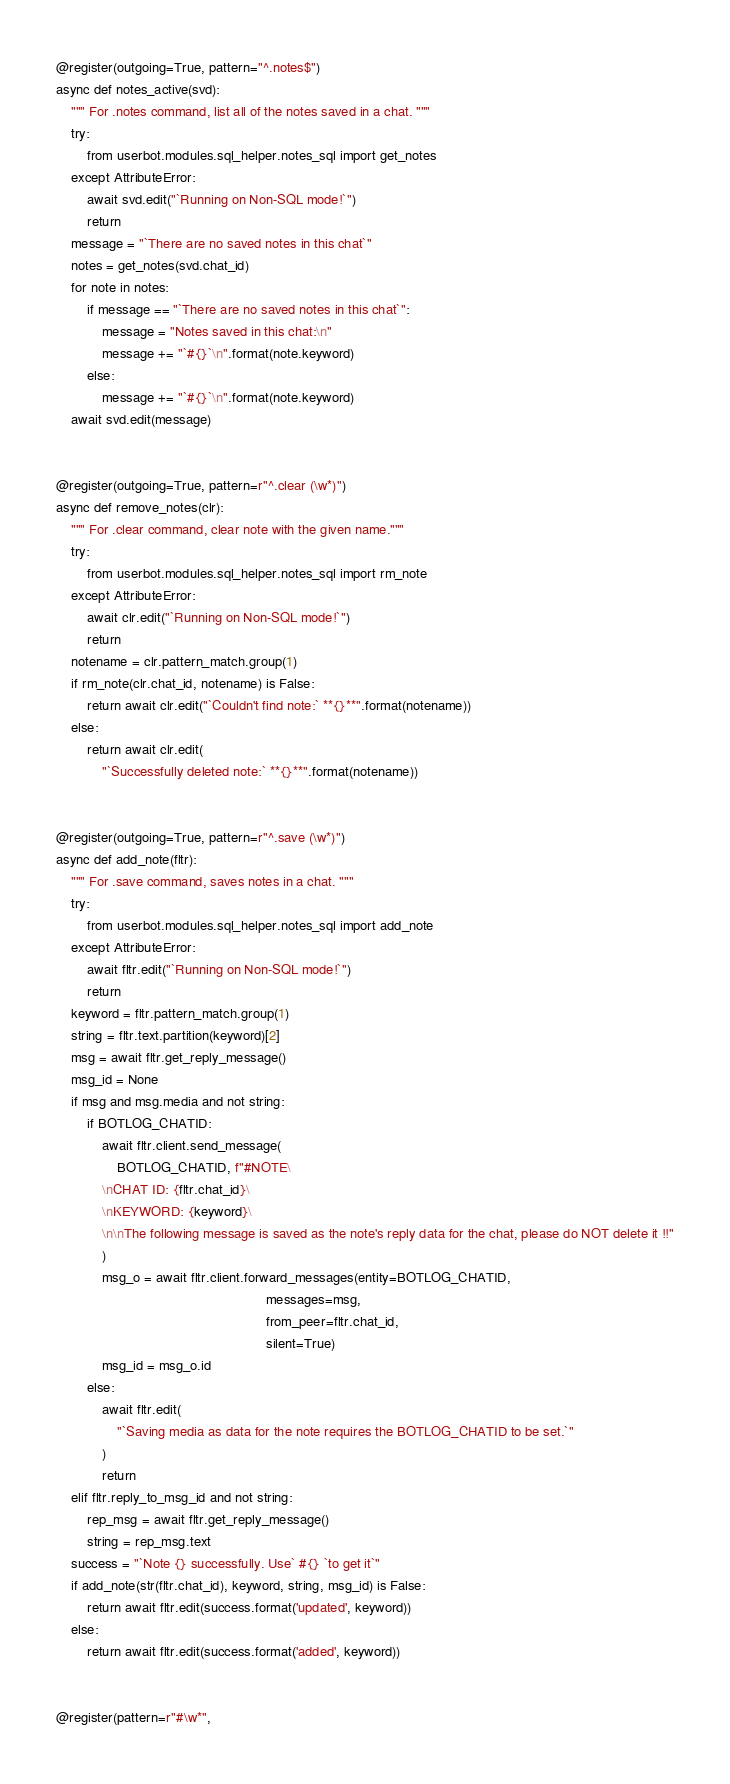<code> <loc_0><loc_0><loc_500><loc_500><_Python_>@register(outgoing=True, pattern="^.notes$")
async def notes_active(svd):
    """ For .notes command, list all of the notes saved in a chat. """
    try:
        from userbot.modules.sql_helper.notes_sql import get_notes
    except AttributeError:
        await svd.edit("`Running on Non-SQL mode!`")
        return
    message = "`There are no saved notes in this chat`"
    notes = get_notes(svd.chat_id)
    for note in notes:
        if message == "`There are no saved notes in this chat`":
            message = "Notes saved in this chat:\n"
            message += "`#{}`\n".format(note.keyword)
        else:
            message += "`#{}`\n".format(note.keyword)
    await svd.edit(message)


@register(outgoing=True, pattern=r"^.clear (\w*)")
async def remove_notes(clr):
    """ For .clear command, clear note with the given name."""
    try:
        from userbot.modules.sql_helper.notes_sql import rm_note
    except AttributeError:
        await clr.edit("`Running on Non-SQL mode!`")
        return
    notename = clr.pattern_match.group(1)
    if rm_note(clr.chat_id, notename) is False:
        return await clr.edit("`Couldn't find note:` **{}**".format(notename))
    else:
        return await clr.edit(
            "`Successfully deleted note:` **{}**".format(notename))


@register(outgoing=True, pattern=r"^.save (\w*)")
async def add_note(fltr):
    """ For .save command, saves notes in a chat. """
    try:
        from userbot.modules.sql_helper.notes_sql import add_note
    except AttributeError:
        await fltr.edit("`Running on Non-SQL mode!`")
        return
    keyword = fltr.pattern_match.group(1)
    string = fltr.text.partition(keyword)[2]
    msg = await fltr.get_reply_message()
    msg_id = None
    if msg and msg.media and not string:
        if BOTLOG_CHATID:
            await fltr.client.send_message(
                BOTLOG_CHATID, f"#NOTE\
            \nCHAT ID: {fltr.chat_id}\
            \nKEYWORD: {keyword}\
            \n\nThe following message is saved as the note's reply data for the chat, please do NOT delete it !!"
            )
            msg_o = await fltr.client.forward_messages(entity=BOTLOG_CHATID,
                                                       messages=msg,
                                                       from_peer=fltr.chat_id,
                                                       silent=True)
            msg_id = msg_o.id
        else:
            await fltr.edit(
                "`Saving media as data for the note requires the BOTLOG_CHATID to be set.`"
            )
            return
    elif fltr.reply_to_msg_id and not string:
        rep_msg = await fltr.get_reply_message()
        string = rep_msg.text
    success = "`Note {} successfully. Use` #{} `to get it`"
    if add_note(str(fltr.chat_id), keyword, string, msg_id) is False:
        return await fltr.edit(success.format('updated', keyword))
    else:
        return await fltr.edit(success.format('added', keyword))


@register(pattern=r"#\w*",</code> 